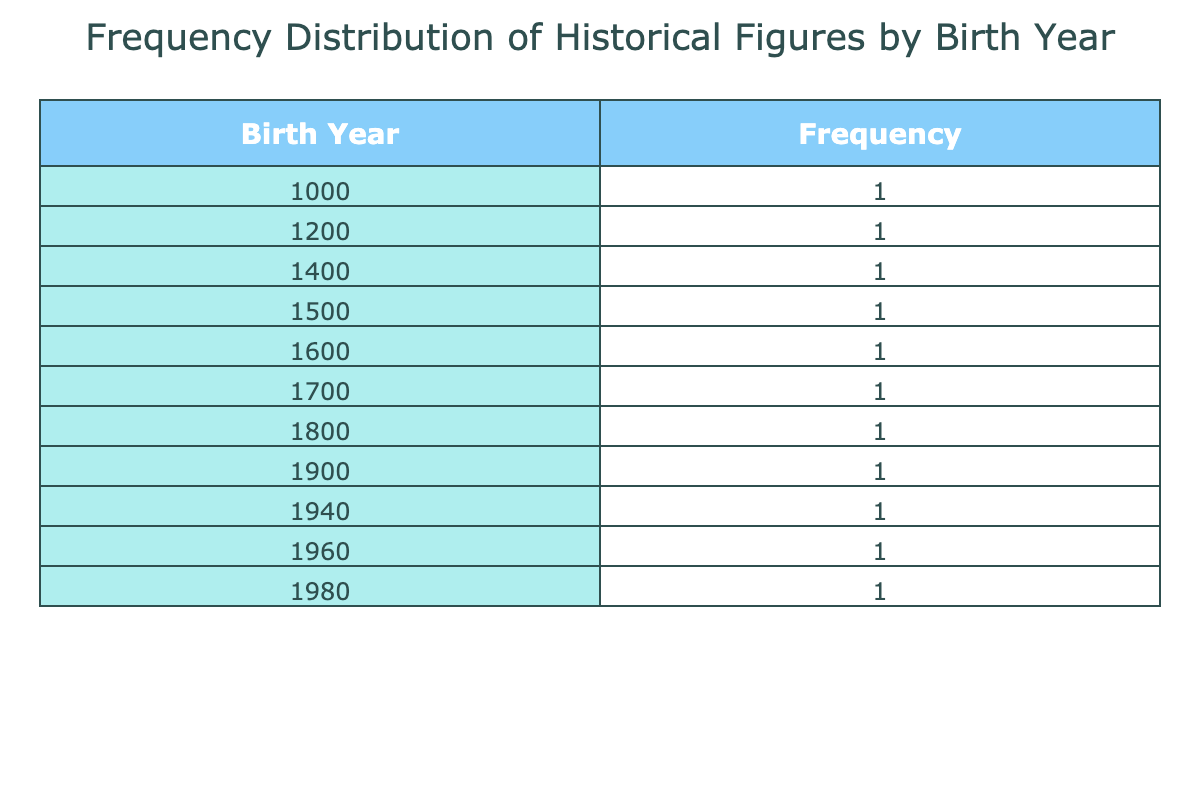What is the birth year of Leonardo da Vinci? The table lists Leonardo da Vinci in the row with the birth year column showing "1400". Thus, his birth year is directly available in the table.
Answer: 1400 Who was born in the year 1960? Looking at the birth years in the table, the figure associated with the year "1960" is Rachel Carson. This information is found in the same row corresponding to that birth year.
Answer: Rachel Carson How many historical figures were born in the 1500s? The table shows that Martin Luther was born in 1500, and there are no other entries from the 1500s. Therefore, the count of figures from that decade is just 1.
Answer: 1 What is the range of birth years represented in the table? The earliest birth year is 1000 (Leif Erikson) and the latest is 1980 (Barack Obama). To find the range, subtract the earliest from the latest: 1980 - 1000 = 980. Thus, the range of birth years is 980 years.
Answer: 980 Are there more scientists or artists in this table? The table lists two scientists (Galileo Galilei and Charles Darwin) and one artist (Leonardo da Vinci). Comparing these counts, there are more scientists (2) than artists (1). Therefore, the answer is affirmative.
Answer: Yes What is the total number of historical figures listed in the table? To find the total, we count each row in the frequency distribution table. There are 11 distinct entries for historical figures. Thus, the total number is 11.
Answer: 11 Which historical figure was born the earliest and what year were they born? The first entry in the table shows Leif Erikson was born in the year 1000. This is the earliest date in the entire table. Hence, Leif Erikson is the earliest figure listed, with the year being 1000.
Answer: Leif Erikson, 1000 Which field has the highest representation of historical figures? The table shows 2 figures from the fields of Science, 3 from other distinct fields (based on their unique category). Since Science has 2 figures and is the highest count compared with others like Politics, Art, etc., it holds the highest representation.
Answer: Science What is the frequency of figures born in the 1900s compared to the 1800s? The table indicates that there are two figures from the 1900s (Albert Einstein and Martin Luther King Jr.) and one from the 1800s (Charles Darwin). Thus, we find that the frequency from the 1900s (2) exceeds that of the 1800s (1).
Answer: 2 in 1900s, 1 in 1800s; more in 1900s 